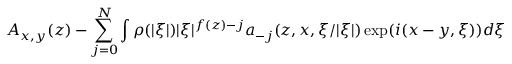Convert formula to latex. <formula><loc_0><loc_0><loc_500><loc_500>A _ { x , y } ( z ) - \sum _ { j = 0 } ^ { N } \int \rho ( | \xi | ) | \xi | ^ { f ( z ) - j } a _ { - j } ( z , x , \xi / | \xi | ) \exp ( i ( x - y , \xi ) ) d \xi</formula> 